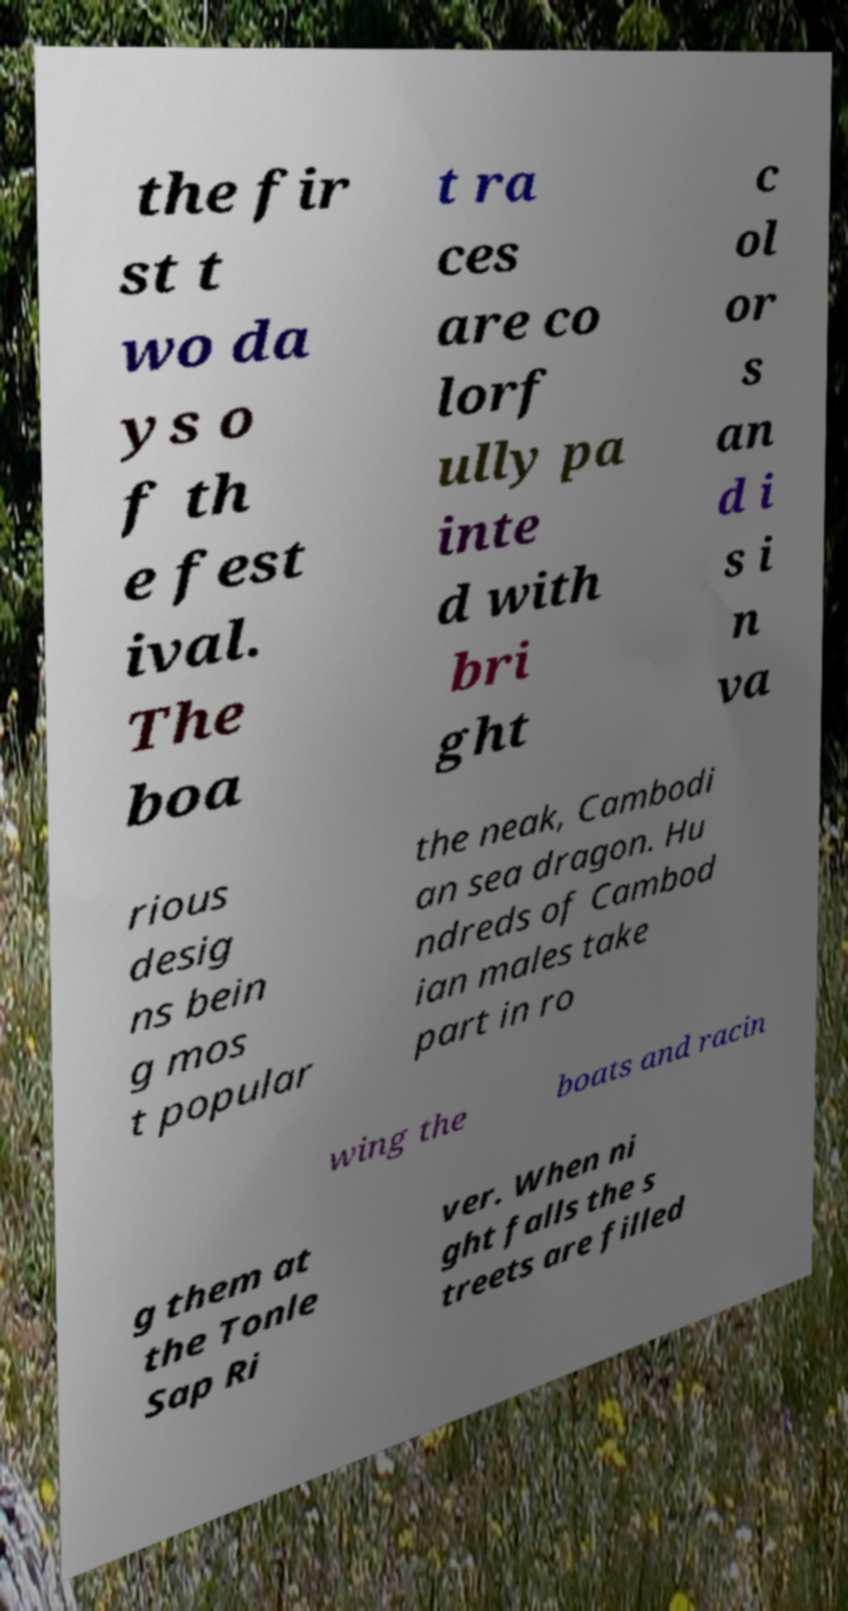What messages or text are displayed in this image? I need them in a readable, typed format. the fir st t wo da ys o f th e fest ival. The boa t ra ces are co lorf ully pa inte d with bri ght c ol or s an d i s i n va rious desig ns bein g mos t popular the neak, Cambodi an sea dragon. Hu ndreds of Cambod ian males take part in ro wing the boats and racin g them at the Tonle Sap Ri ver. When ni ght falls the s treets are filled 